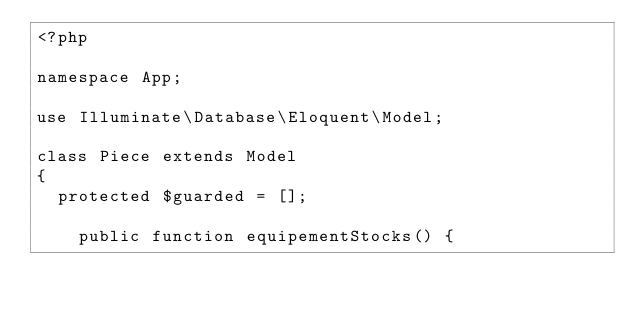Convert code to text. <code><loc_0><loc_0><loc_500><loc_500><_PHP_><?php

namespace App;

use Illuminate\Database\Eloquent\Model;

class Piece extends Model
{
	protected $guarded = [];
	
    public function equipementStocks() {</code> 